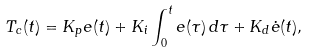Convert formula to latex. <formula><loc_0><loc_0><loc_500><loc_500>T _ { c } ( t ) = K _ { p } e ( t ) + K _ { i } \int _ { 0 } ^ { t } e ( \tau ) \, d \tau + K _ { d } { \dot { e } } ( t ) ,</formula> 